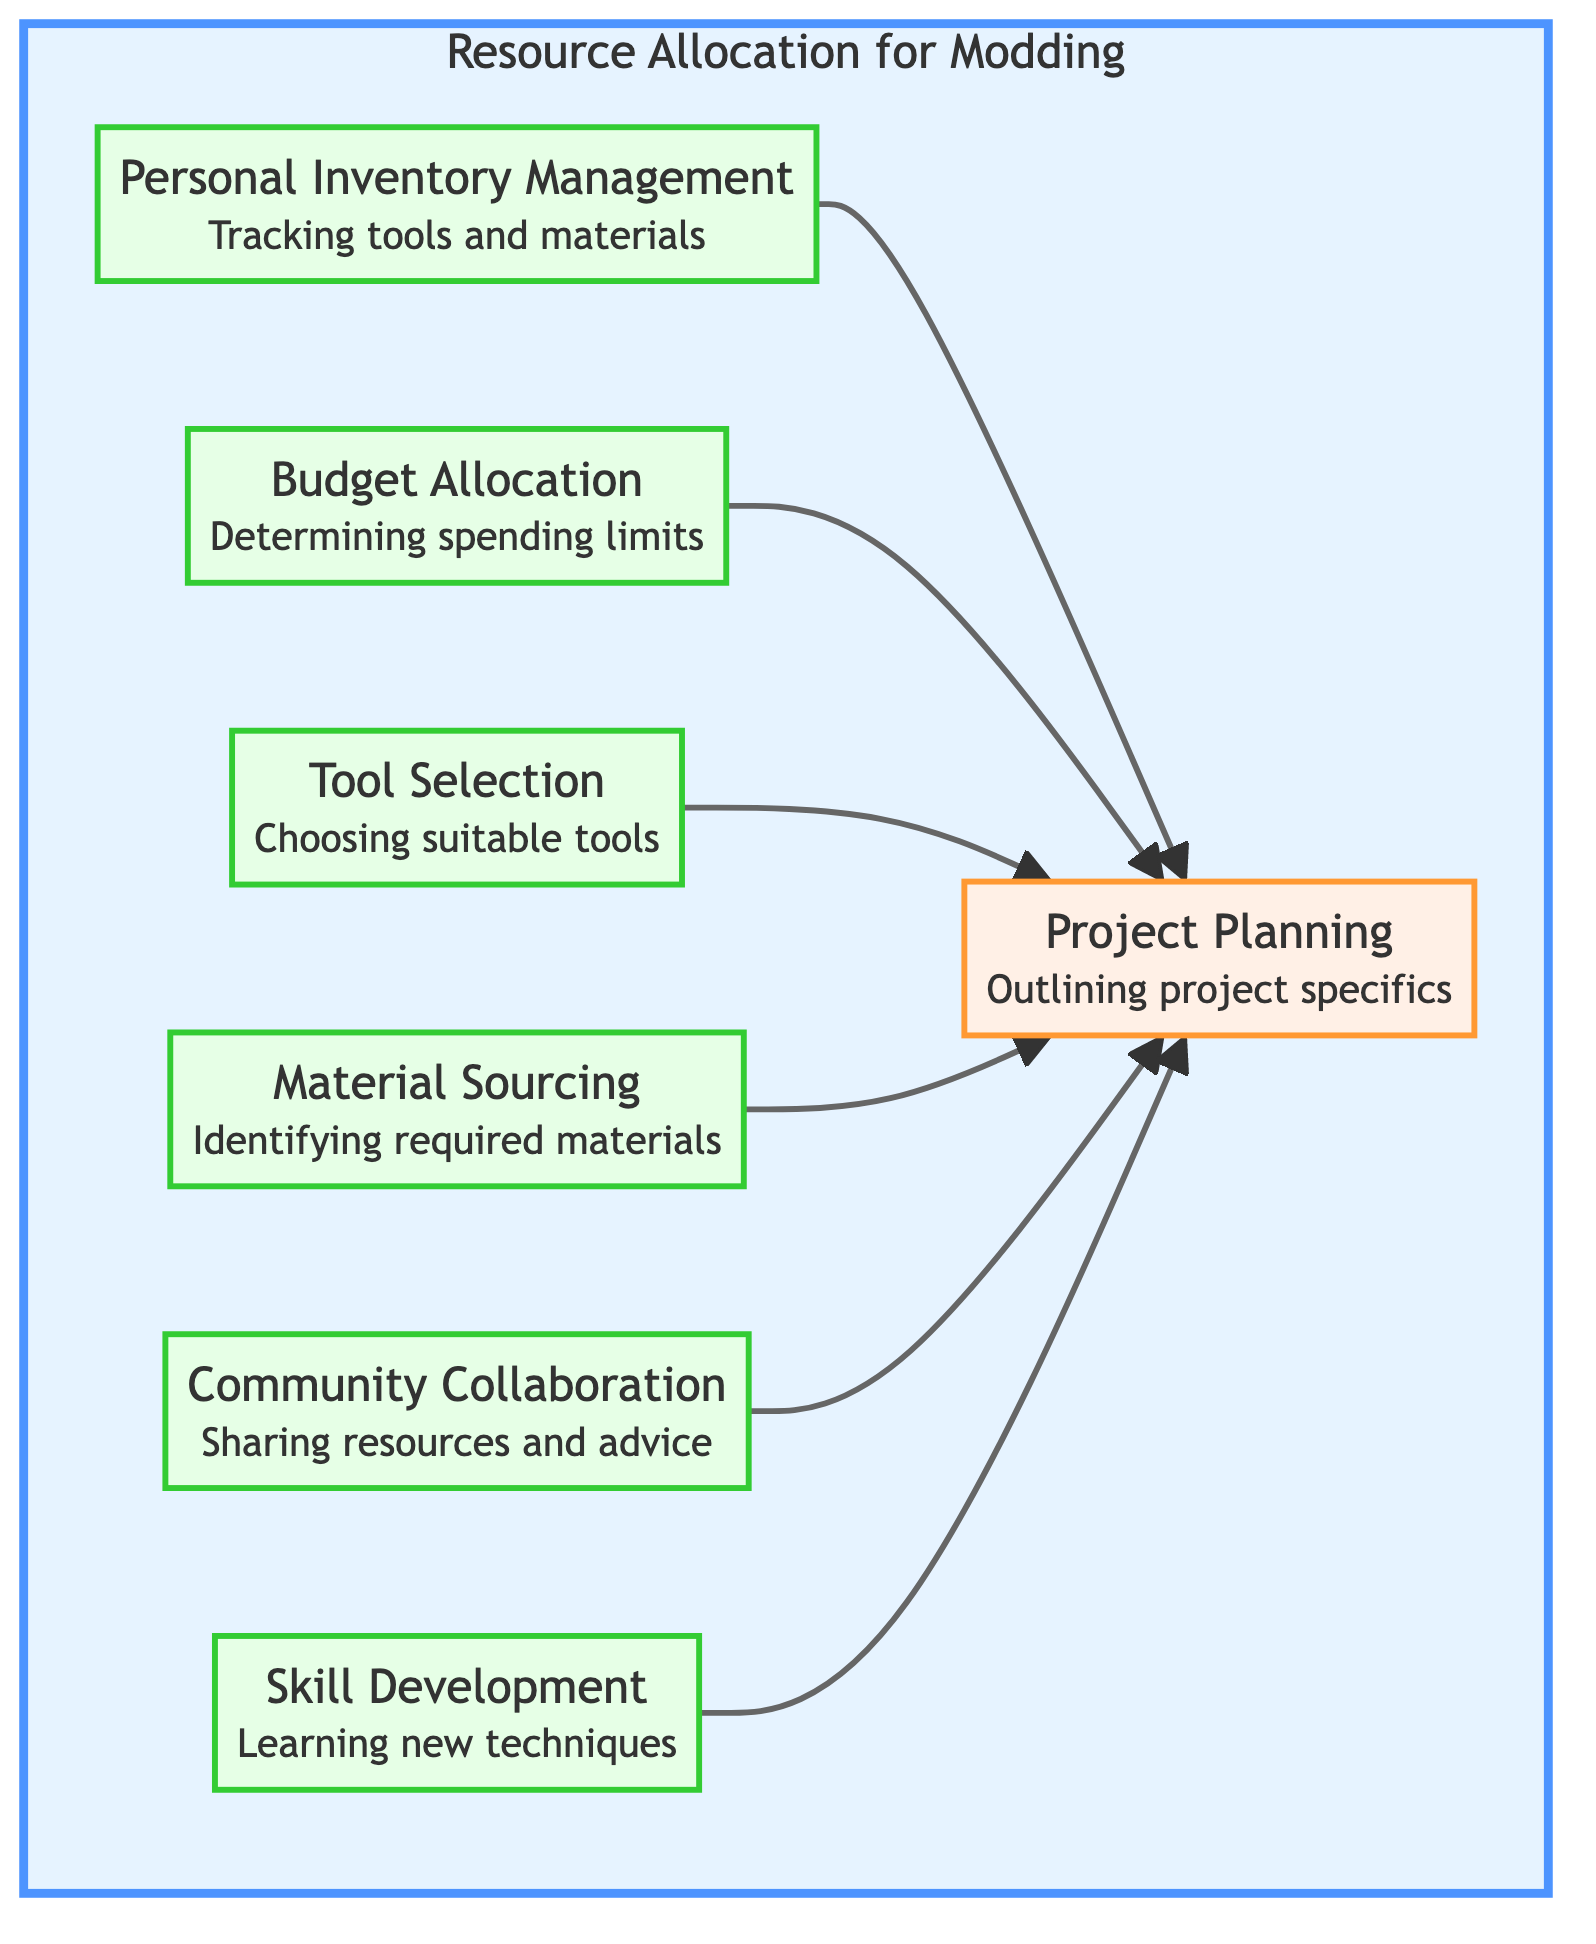What is the main focus of the diagram? The diagram is centered around "Resource Allocation for Modding" as indicated in the title of the subgraph. This suggests that all elements contribute towards a structured approach to managing resources for modding.
Answer: Resource Allocation for Modding How many elements are included in the diagram? The diagram contains a total of 7 elements, which include Personal Inventory Management, Budget Allocation, Tool Selection, Material Sourcing, Community Collaboration, Skill Development, and Project Planning.
Answer: 7 Which element is at the base of the flow? The element that serves as the primary focus, receiving inputs from all other elements, is "Project Planning" at the base level of the flow chart.
Answer: Project Planning What types of external contributions are acknowledged in the diagram? The diagram includes "Community Collaboration" which emphasizes the importance of engaging with fellow modders for sharing resources and advice related to tools and materials.
Answer: Community Collaboration What is the relationship between "Budget Allocation" and "Project Planning"? "Budget Allocation" directly leads into "Project Planning," indicating that deciding on a budget is a preliminary step that informs project specifics.
Answer: Direct relationship Which elements are focused on skill enhancement? "Skill Development" is the sole element that is dedicated to investing time and learning new techniques or improving existing skills relevant to modding.
Answer: Skill Development What type of materials is mentioned for sourcing? "Material Sourcing" specifies the identification and sourcing of materials required for mods, which can include plastics, metals, or electronics.
Answer: Plastics, metals, or electronics How does "Personal Inventory Management" contribute to the process? "Personal Inventory Management" contributes by tracking available tools and materials, which then influences "Project Planning" to accurately reflect what is on hand.
Answer: Tracking tools and materials Which element involves interaction with the modding community? "Community Collaboration" is the element that involves engaging with other modders to share resources and advice on tool usage and material selection.
Answer: Community Collaboration 